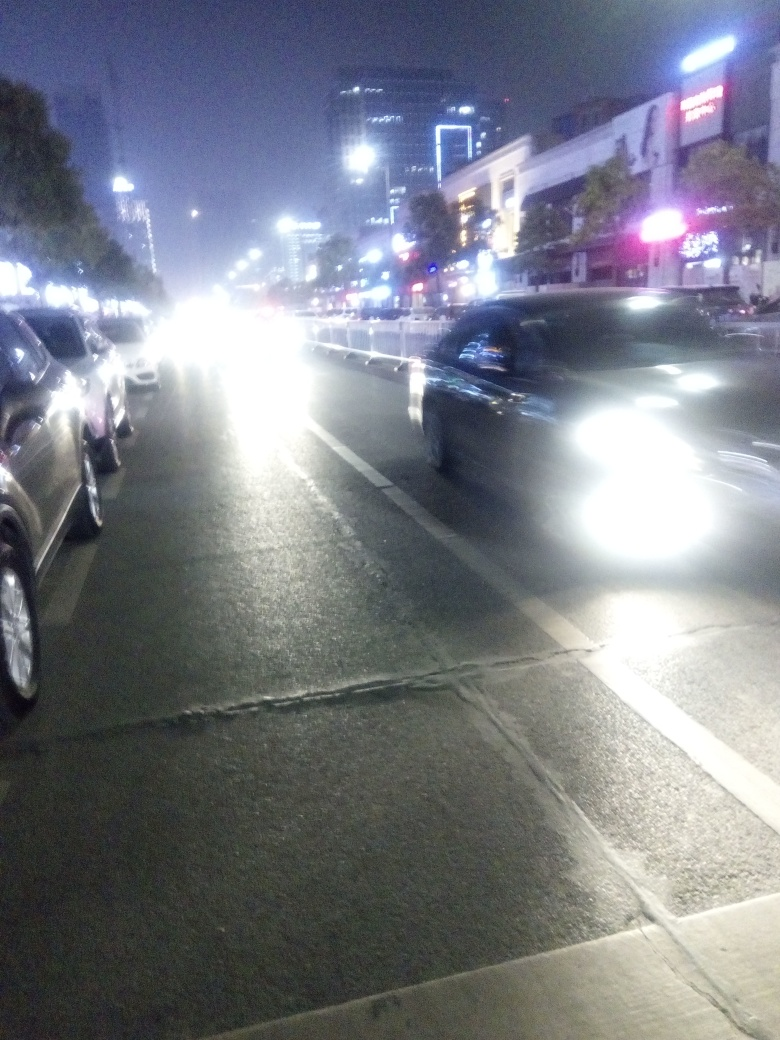Can you describe the lighting conditions and how they might affect the visibility of this scene? The lighting conditions in the image are subdued, with a combination of the city's ambient illumination and the glare from vehicle headlights. These conditions create a challenging environment for capturing clear images, often resulting in overexposure where the light sources are, and underexposure in the surrounding areas. 